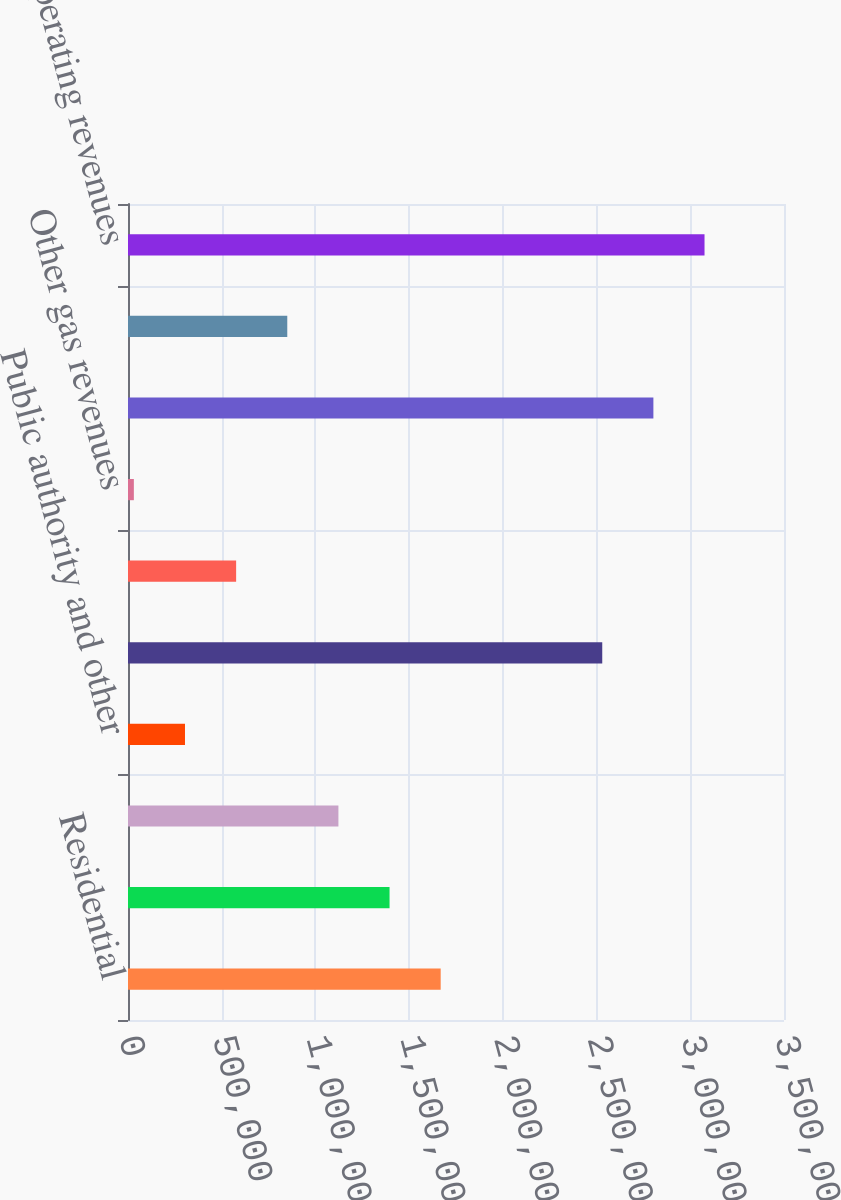Convert chart to OTSL. <chart><loc_0><loc_0><loc_500><loc_500><bar_chart><fcel>Residential<fcel>Commercial<fcel>Industrial<fcel>Public authority and other<fcel>Total gas sales revenues<fcel>Transportation revenues<fcel>Other gas revenues<fcel>Total distribution revenues<fcel>Pipeline and storage revenues<fcel>Total operating revenues<nl><fcel>1.66832e+06<fcel>1.39547e+06<fcel>1.12262e+06<fcel>304057<fcel>2.53028e+06<fcel>576910<fcel>31204<fcel>2.80313e+06<fcel>849763<fcel>3.07598e+06<nl></chart> 